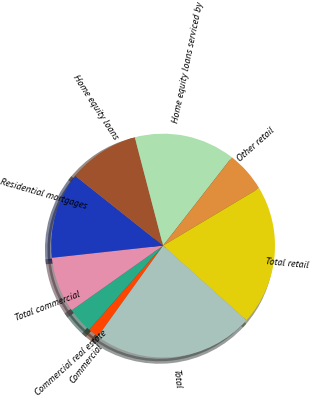<chart> <loc_0><loc_0><loc_500><loc_500><pie_chart><fcel>Commercial<fcel>Commercial real estate<fcel>Total commercial<fcel>Residential mortgages<fcel>Home equity loans<fcel>Home equity loans serviced by<fcel>Other retail<fcel>Total retail<fcel>Total<nl><fcel>1.55%<fcel>3.73%<fcel>8.07%<fcel>12.42%<fcel>10.25%<fcel>14.6%<fcel>5.9%<fcel>20.19%<fcel>23.29%<nl></chart> 